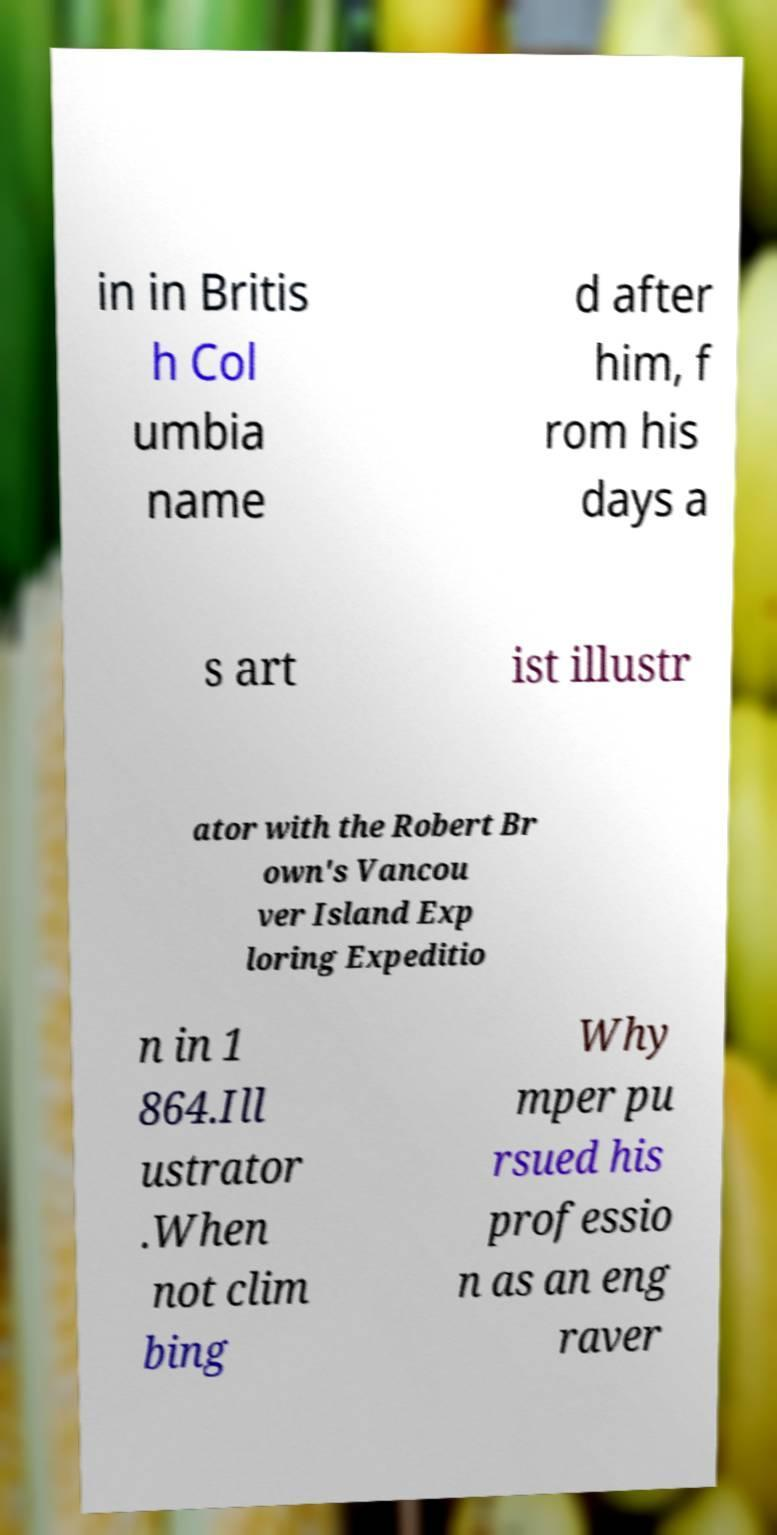I need the written content from this picture converted into text. Can you do that? in in Britis h Col umbia name d after him, f rom his days a s art ist illustr ator with the Robert Br own's Vancou ver Island Exp loring Expeditio n in 1 864.Ill ustrator .When not clim bing Why mper pu rsued his professio n as an eng raver 